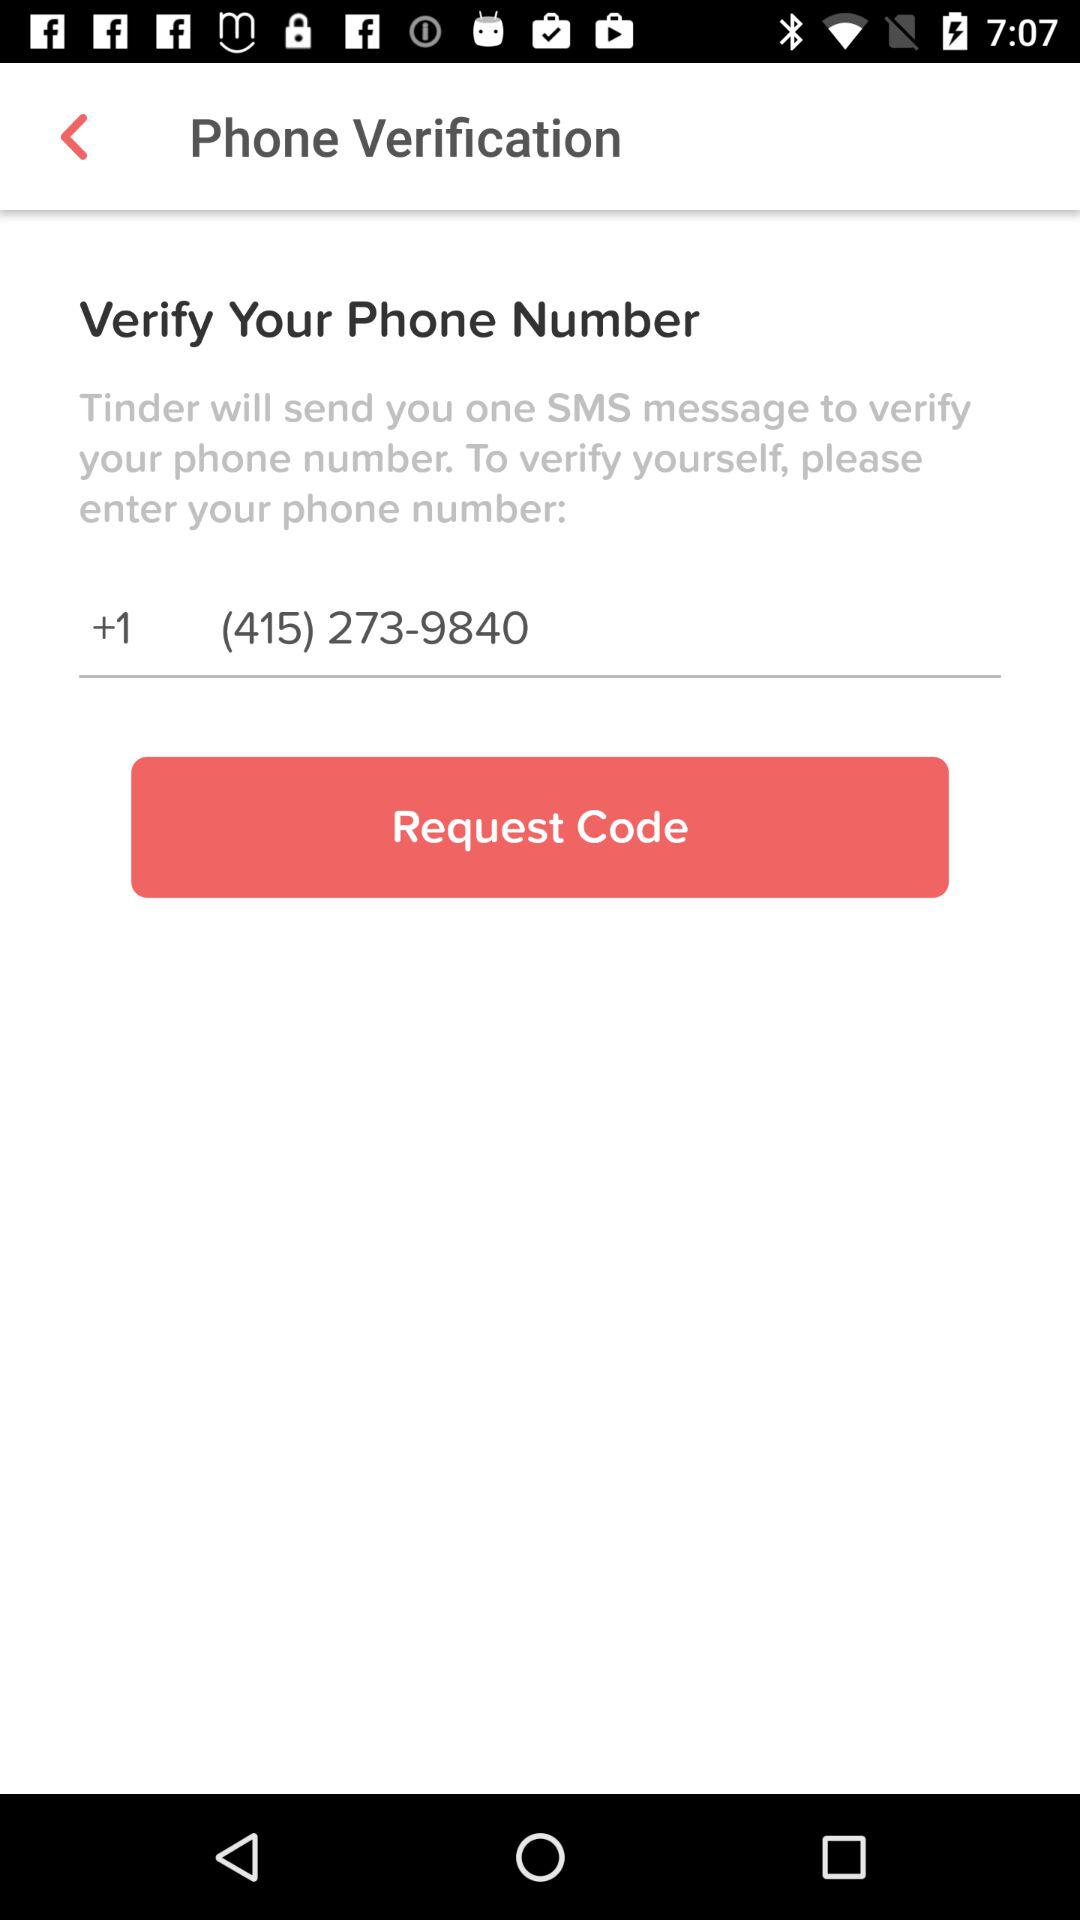Which application will send the SMS message to verify? The SMS will be sent by "Tinder" to verify. 